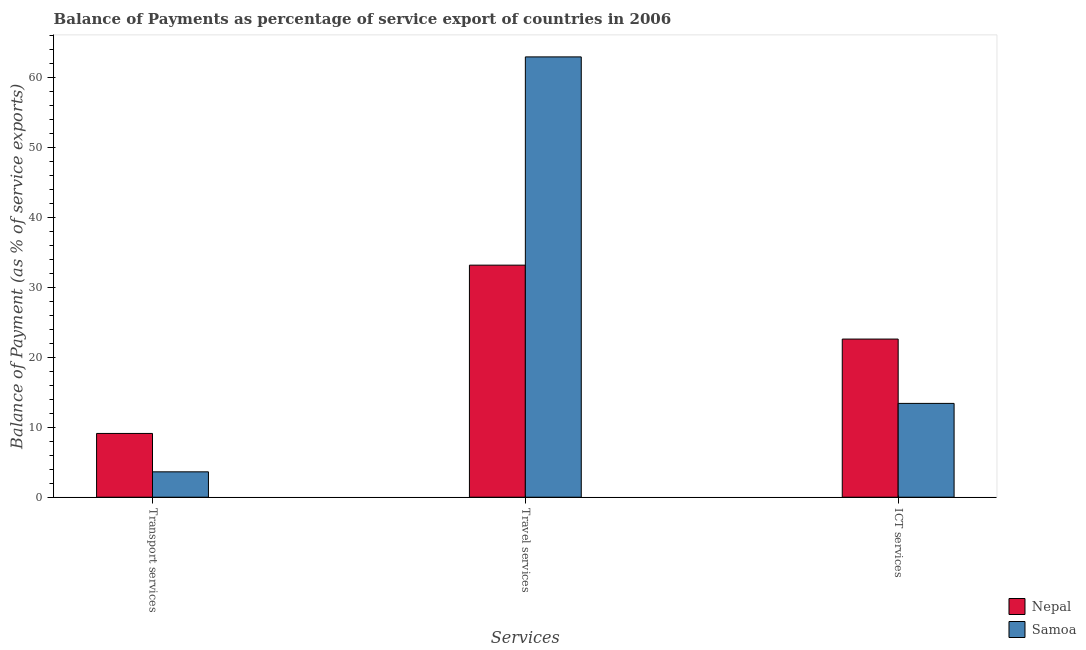How many groups of bars are there?
Your response must be concise. 3. Are the number of bars per tick equal to the number of legend labels?
Provide a short and direct response. Yes. What is the label of the 2nd group of bars from the left?
Your answer should be compact. Travel services. What is the balance of payment of ict services in Samoa?
Offer a terse response. 13.4. Across all countries, what is the maximum balance of payment of ict services?
Your answer should be compact. 22.59. Across all countries, what is the minimum balance of payment of ict services?
Offer a terse response. 13.4. In which country was the balance of payment of travel services maximum?
Your answer should be very brief. Samoa. In which country was the balance of payment of transport services minimum?
Offer a terse response. Samoa. What is the total balance of payment of transport services in the graph?
Your answer should be very brief. 12.73. What is the difference between the balance of payment of transport services in Samoa and that in Nepal?
Your answer should be compact. -5.48. What is the difference between the balance of payment of ict services in Samoa and the balance of payment of transport services in Nepal?
Ensure brevity in your answer.  4.29. What is the average balance of payment of ict services per country?
Your answer should be compact. 17.99. What is the difference between the balance of payment of transport services and balance of payment of ict services in Samoa?
Ensure brevity in your answer.  -9.77. What is the ratio of the balance of payment of transport services in Samoa to that in Nepal?
Your answer should be very brief. 0.4. Is the balance of payment of travel services in Nepal less than that in Samoa?
Provide a short and direct response. Yes. What is the difference between the highest and the second highest balance of payment of ict services?
Offer a very short reply. 9.19. What is the difference between the highest and the lowest balance of payment of transport services?
Offer a very short reply. 5.48. Is the sum of the balance of payment of transport services in Nepal and Samoa greater than the maximum balance of payment of travel services across all countries?
Give a very brief answer. No. What does the 1st bar from the left in Transport services represents?
Keep it short and to the point. Nepal. What does the 1st bar from the right in Travel services represents?
Make the answer very short. Samoa. What is the difference between two consecutive major ticks on the Y-axis?
Provide a succinct answer. 10. Does the graph contain any zero values?
Make the answer very short. No. Where does the legend appear in the graph?
Give a very brief answer. Bottom right. What is the title of the graph?
Your answer should be very brief. Balance of Payments as percentage of service export of countries in 2006. What is the label or title of the X-axis?
Offer a very short reply. Services. What is the label or title of the Y-axis?
Keep it short and to the point. Balance of Payment (as % of service exports). What is the Balance of Payment (as % of service exports) of Nepal in Transport services?
Offer a terse response. 9.11. What is the Balance of Payment (as % of service exports) of Samoa in Transport services?
Make the answer very short. 3.63. What is the Balance of Payment (as % of service exports) in Nepal in Travel services?
Your answer should be compact. 33.14. What is the Balance of Payment (as % of service exports) of Samoa in Travel services?
Provide a succinct answer. 62.88. What is the Balance of Payment (as % of service exports) in Nepal in ICT services?
Offer a very short reply. 22.59. What is the Balance of Payment (as % of service exports) in Samoa in ICT services?
Your answer should be compact. 13.4. Across all Services, what is the maximum Balance of Payment (as % of service exports) of Nepal?
Offer a terse response. 33.14. Across all Services, what is the maximum Balance of Payment (as % of service exports) in Samoa?
Give a very brief answer. 62.88. Across all Services, what is the minimum Balance of Payment (as % of service exports) in Nepal?
Make the answer very short. 9.11. Across all Services, what is the minimum Balance of Payment (as % of service exports) of Samoa?
Provide a short and direct response. 3.63. What is the total Balance of Payment (as % of service exports) of Nepal in the graph?
Make the answer very short. 64.84. What is the total Balance of Payment (as % of service exports) in Samoa in the graph?
Give a very brief answer. 79.91. What is the difference between the Balance of Payment (as % of service exports) in Nepal in Transport services and that in Travel services?
Ensure brevity in your answer.  -24.03. What is the difference between the Balance of Payment (as % of service exports) in Samoa in Transport services and that in Travel services?
Make the answer very short. -59.26. What is the difference between the Balance of Payment (as % of service exports) of Nepal in Transport services and that in ICT services?
Ensure brevity in your answer.  -13.48. What is the difference between the Balance of Payment (as % of service exports) in Samoa in Transport services and that in ICT services?
Offer a terse response. -9.77. What is the difference between the Balance of Payment (as % of service exports) of Nepal in Travel services and that in ICT services?
Make the answer very short. 10.56. What is the difference between the Balance of Payment (as % of service exports) of Samoa in Travel services and that in ICT services?
Keep it short and to the point. 49.49. What is the difference between the Balance of Payment (as % of service exports) in Nepal in Transport services and the Balance of Payment (as % of service exports) in Samoa in Travel services?
Provide a short and direct response. -53.78. What is the difference between the Balance of Payment (as % of service exports) of Nepal in Transport services and the Balance of Payment (as % of service exports) of Samoa in ICT services?
Your answer should be very brief. -4.29. What is the difference between the Balance of Payment (as % of service exports) of Nepal in Travel services and the Balance of Payment (as % of service exports) of Samoa in ICT services?
Your answer should be very brief. 19.74. What is the average Balance of Payment (as % of service exports) of Nepal per Services?
Provide a succinct answer. 21.61. What is the average Balance of Payment (as % of service exports) in Samoa per Services?
Keep it short and to the point. 26.64. What is the difference between the Balance of Payment (as % of service exports) of Nepal and Balance of Payment (as % of service exports) of Samoa in Transport services?
Your answer should be compact. 5.48. What is the difference between the Balance of Payment (as % of service exports) in Nepal and Balance of Payment (as % of service exports) in Samoa in Travel services?
Your response must be concise. -29.74. What is the difference between the Balance of Payment (as % of service exports) in Nepal and Balance of Payment (as % of service exports) in Samoa in ICT services?
Make the answer very short. 9.19. What is the ratio of the Balance of Payment (as % of service exports) in Nepal in Transport services to that in Travel services?
Provide a succinct answer. 0.27. What is the ratio of the Balance of Payment (as % of service exports) in Samoa in Transport services to that in Travel services?
Provide a short and direct response. 0.06. What is the ratio of the Balance of Payment (as % of service exports) of Nepal in Transport services to that in ICT services?
Provide a succinct answer. 0.4. What is the ratio of the Balance of Payment (as % of service exports) of Samoa in Transport services to that in ICT services?
Make the answer very short. 0.27. What is the ratio of the Balance of Payment (as % of service exports) in Nepal in Travel services to that in ICT services?
Give a very brief answer. 1.47. What is the ratio of the Balance of Payment (as % of service exports) in Samoa in Travel services to that in ICT services?
Provide a short and direct response. 4.69. What is the difference between the highest and the second highest Balance of Payment (as % of service exports) in Nepal?
Offer a terse response. 10.56. What is the difference between the highest and the second highest Balance of Payment (as % of service exports) of Samoa?
Make the answer very short. 49.49. What is the difference between the highest and the lowest Balance of Payment (as % of service exports) of Nepal?
Give a very brief answer. 24.03. What is the difference between the highest and the lowest Balance of Payment (as % of service exports) of Samoa?
Offer a very short reply. 59.26. 